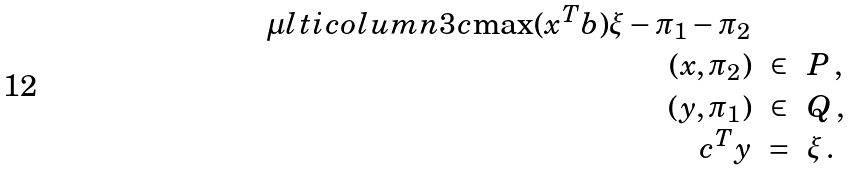Convert formula to latex. <formula><loc_0><loc_0><loc_500><loc_500>\begin{array} { r c l } \mu l t i c o l u m n { 3 } { c } { \max ( x ^ { T } b ) \xi - \pi _ { 1 } - \pi _ { 2 } } \\ ( x , \pi _ { 2 } ) & \in & P \, , \\ ( y , \pi _ { 1 } ) & \in & Q \, , \\ c ^ { T } y & = & \xi \, . \\ \end{array}</formula> 